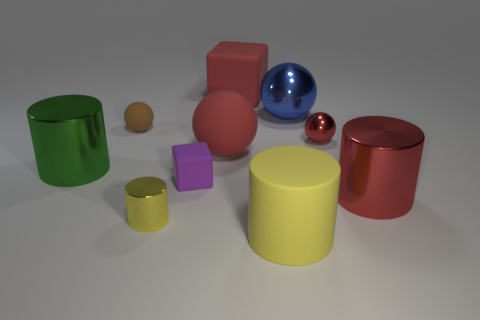What could be the possible sizes of these objects relative to each other? Judging from their relative proportions in the image, the largest objects appear to be the red and green cylinders, followed by the red block. The yellow cylinder seems to be about half the height of the green one, with the purple block being smaller still. The spheres vary in size with the blue one being the largest and the red one the smallest, akin to a marble. These size estimations are speculative, after all, as we don't have a standard reference for scale. 